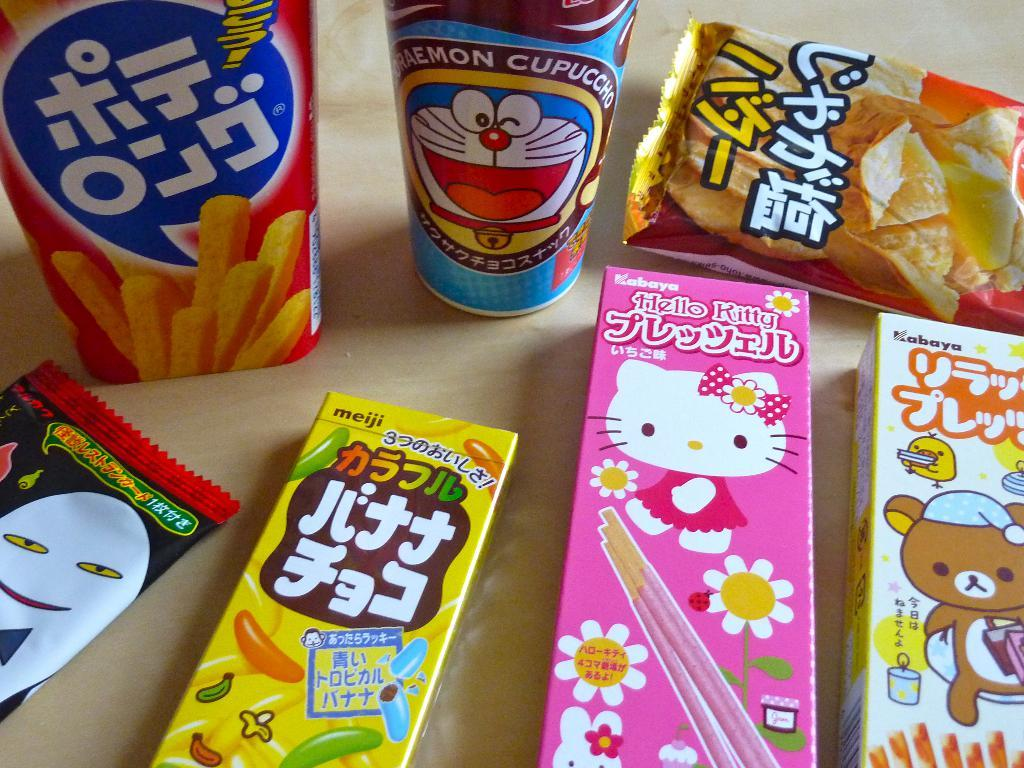How many boxes are on the table in the image? There are three boxes on the table in the image. What other items can be seen on the table besides the boxes? There are two packets and two bottles on the table in the image. What is the color of the background in the image? The background of the image is cream in color. What type of cork can be seen attacking the boxes in the image? There is no cork or attack present in the image; it features three boxes, two packets, and two bottles on a table with a cream-colored background. 